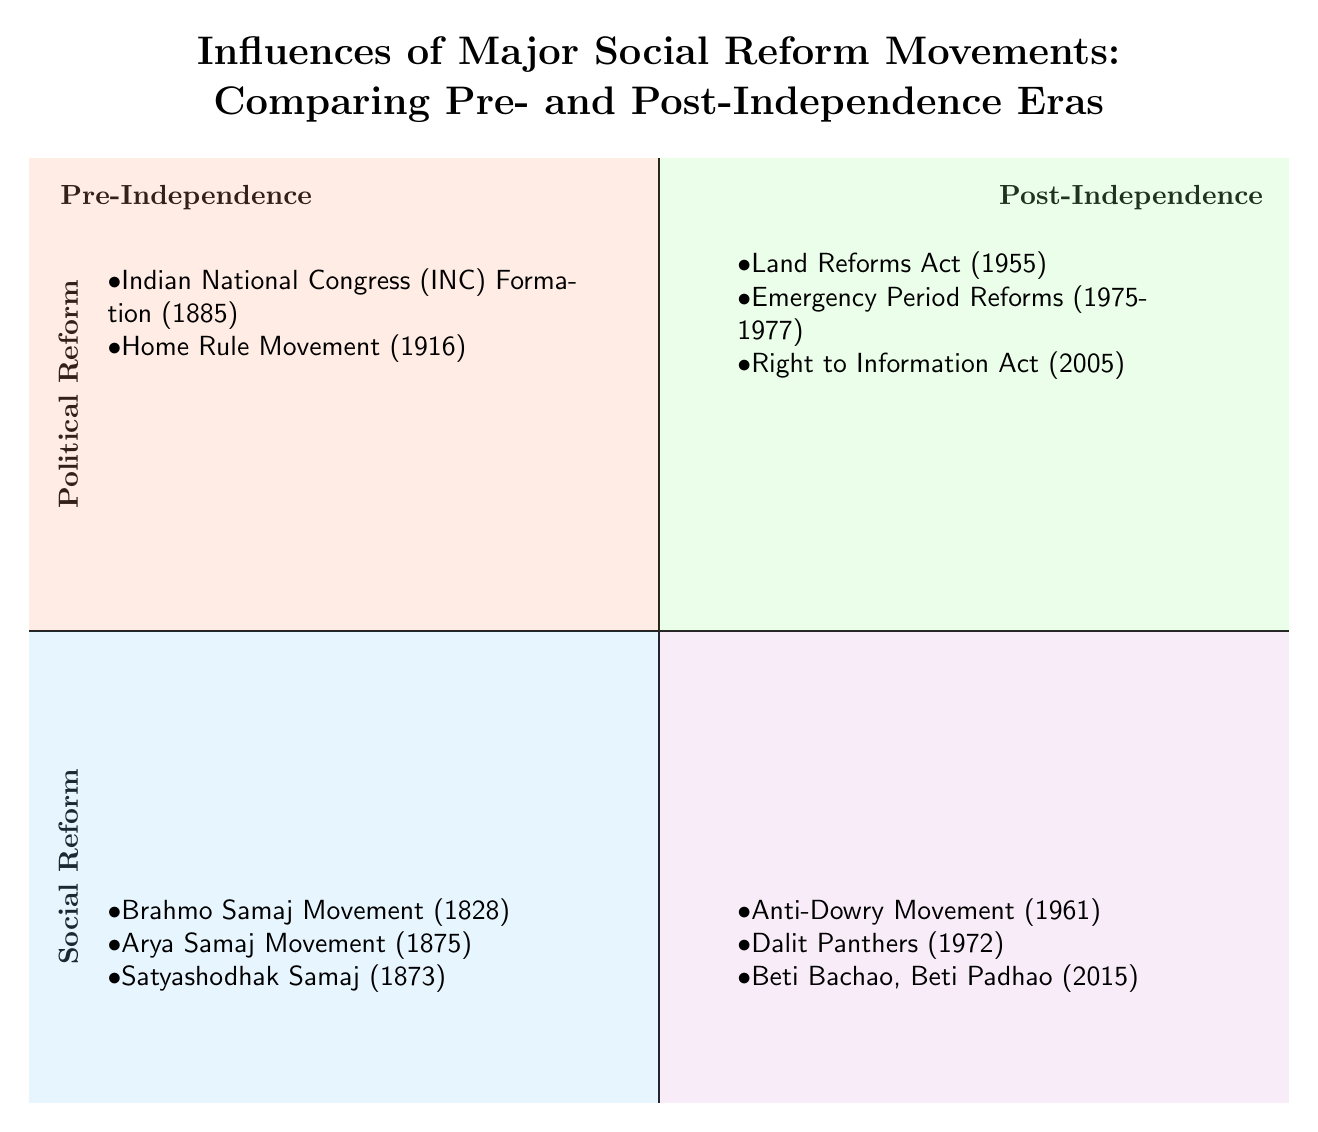What are the two major categories in the diagram? The diagram is divided into two major categories: Political Reform and Social Reform. These categories are indicated in the left and right quadrants for both the Pre-Independence and Post-Independence eras.
Answer: Political Reform, Social Reform How many social reform movements are listed in the Pre-Independence quadrant? In the Pre-Independence quadrant, three social reform movements are listed: Brahmo Samaj Movement, Arya Samaj Movement, and Satyashodhak Samaj. Counting these items gives a total of three.
Answer: 3 Which political reform marked the formation of the Indian National Congress? The formation of the Indian National Congress (INC) in 1885 is marked in the Pre-Independence, Political Reform quadrant. This movement is explicitly mentioned in the diagram.
Answer: Indian National Congress (INC) Formation (1885) What is the latest social reform movement mentioned in the Post-Independence quadrant? The latest social reform movement mentioned in the Post-Independence quadrant is Beti Bachao, Beti Padhao, which was initiated in 2015. This piece of information can be found in the lower right quadrant.
Answer: Beti Bachao, Beti Padhao (2015) What is the relationship between the Home Rule Movement and the Indian National Congress? Both the Home Rule Movement (1916) and the Indian National Congress (INC) Formation (1885) are listed under the Pre-Independence, Political Reform quadrant, indicating they are both significant political movements prior to India's independence.
Answer: Both are significant political reforms pre-Independence Which reform movement focuses on the Right to Information? The Right to Information Act (2005) is listed in the Post-Independence, Political Reform quadrant, indicating it focuses on transparency in governance. Thus, it refers specifically to this act.
Answer: Right to Information Act (2005) How many reform movements are listed in the Post-Independence quadrant? Under the Post-Independence quadrant, there are six reform movements in total: three in Political Reform and three in Social Reform, totaling six items.
Answer: 6 Which quadrant features the Anti-Dowry Movement and how does it relate to the time period? The Anti-Dowry Movement (1961) is featured in the Post-Independence, Social Reform quadrant, indicating it arose after India's independence in 1947. This helps to understand its historical context.
Answer: Post-Independence What significant political reform occurred during the Emergency Period? The Emergency Period Reforms (1975-1977) are specifically mentioned in the Post-Independence, Political Reform quadrant, indicating their significance during a notable crisis period in India’s political history.
Answer: Emergency Period Reforms (1975-1977) 